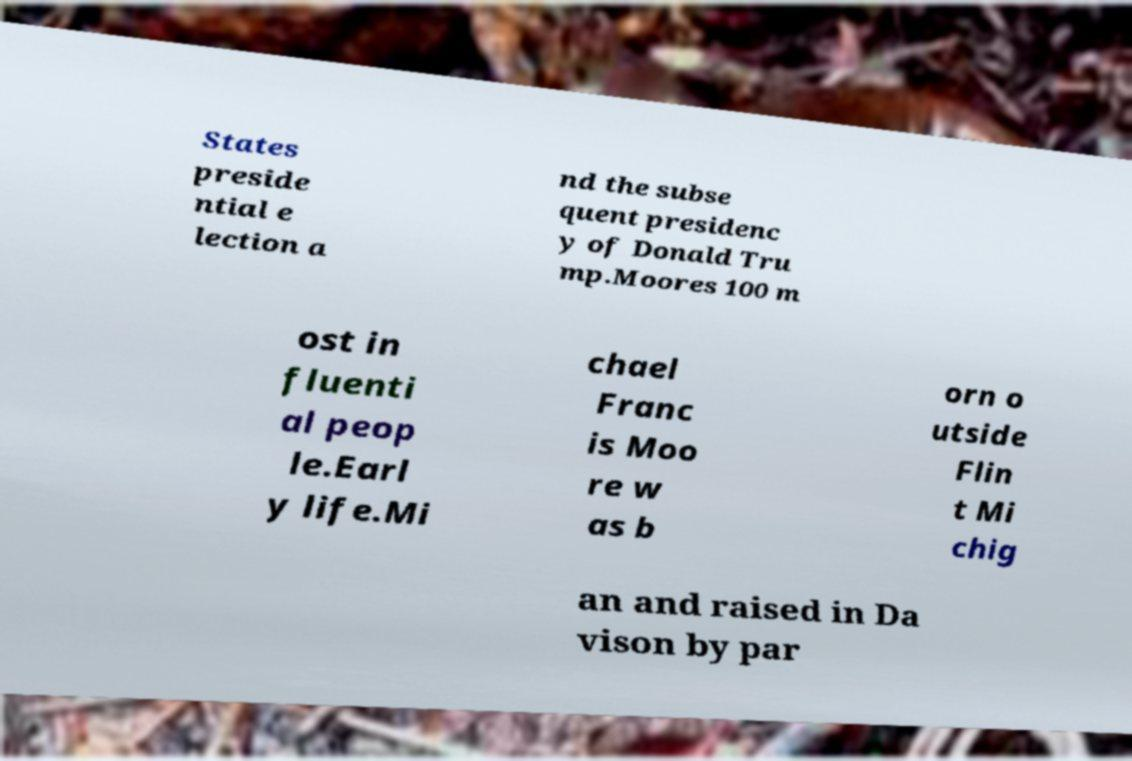Could you assist in decoding the text presented in this image and type it out clearly? States preside ntial e lection a nd the subse quent presidenc y of Donald Tru mp.Moores 100 m ost in fluenti al peop le.Earl y life.Mi chael Franc is Moo re w as b orn o utside Flin t Mi chig an and raised in Da vison by par 